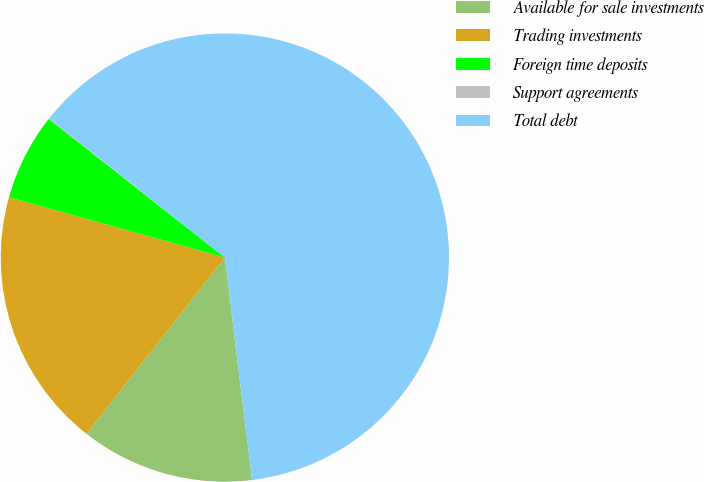Convert chart. <chart><loc_0><loc_0><loc_500><loc_500><pie_chart><fcel>Available for sale investments<fcel>Trading investments<fcel>Foreign time deposits<fcel>Support agreements<fcel>Total debt<nl><fcel>12.52%<fcel>18.75%<fcel>6.28%<fcel>0.05%<fcel>62.4%<nl></chart> 